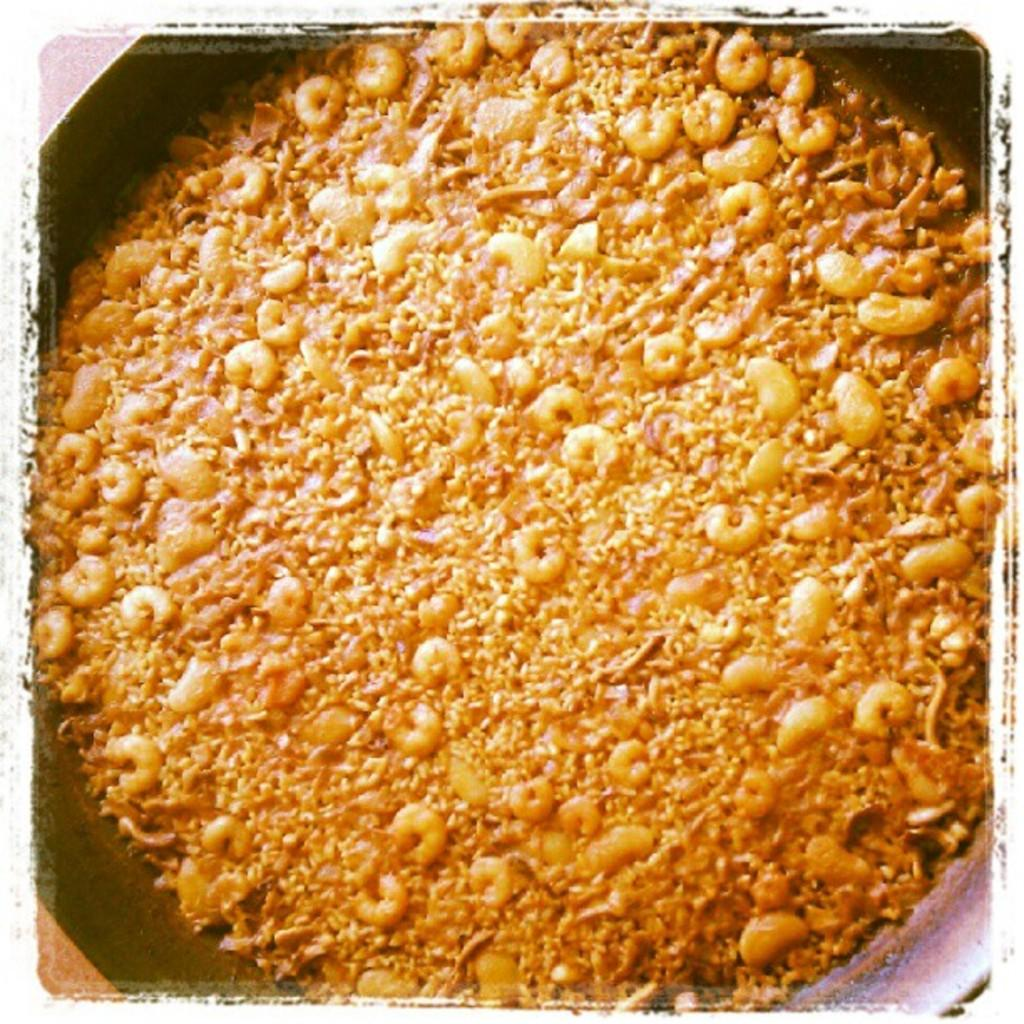What is the main object in the center of the image? There is a pan in the center of the image. What is inside the pan? The pan contains food items. Can you identify the type of food in the pan? The food items appear to be prawns. What type of window can be seen in the pan with the prawns? There is no window present in the image; it features a pan with prawns. How does the loss of the prawns affect the downtown area in the image? There is no mention of loss or downtown area in the image; it only shows a pan with prawns. 